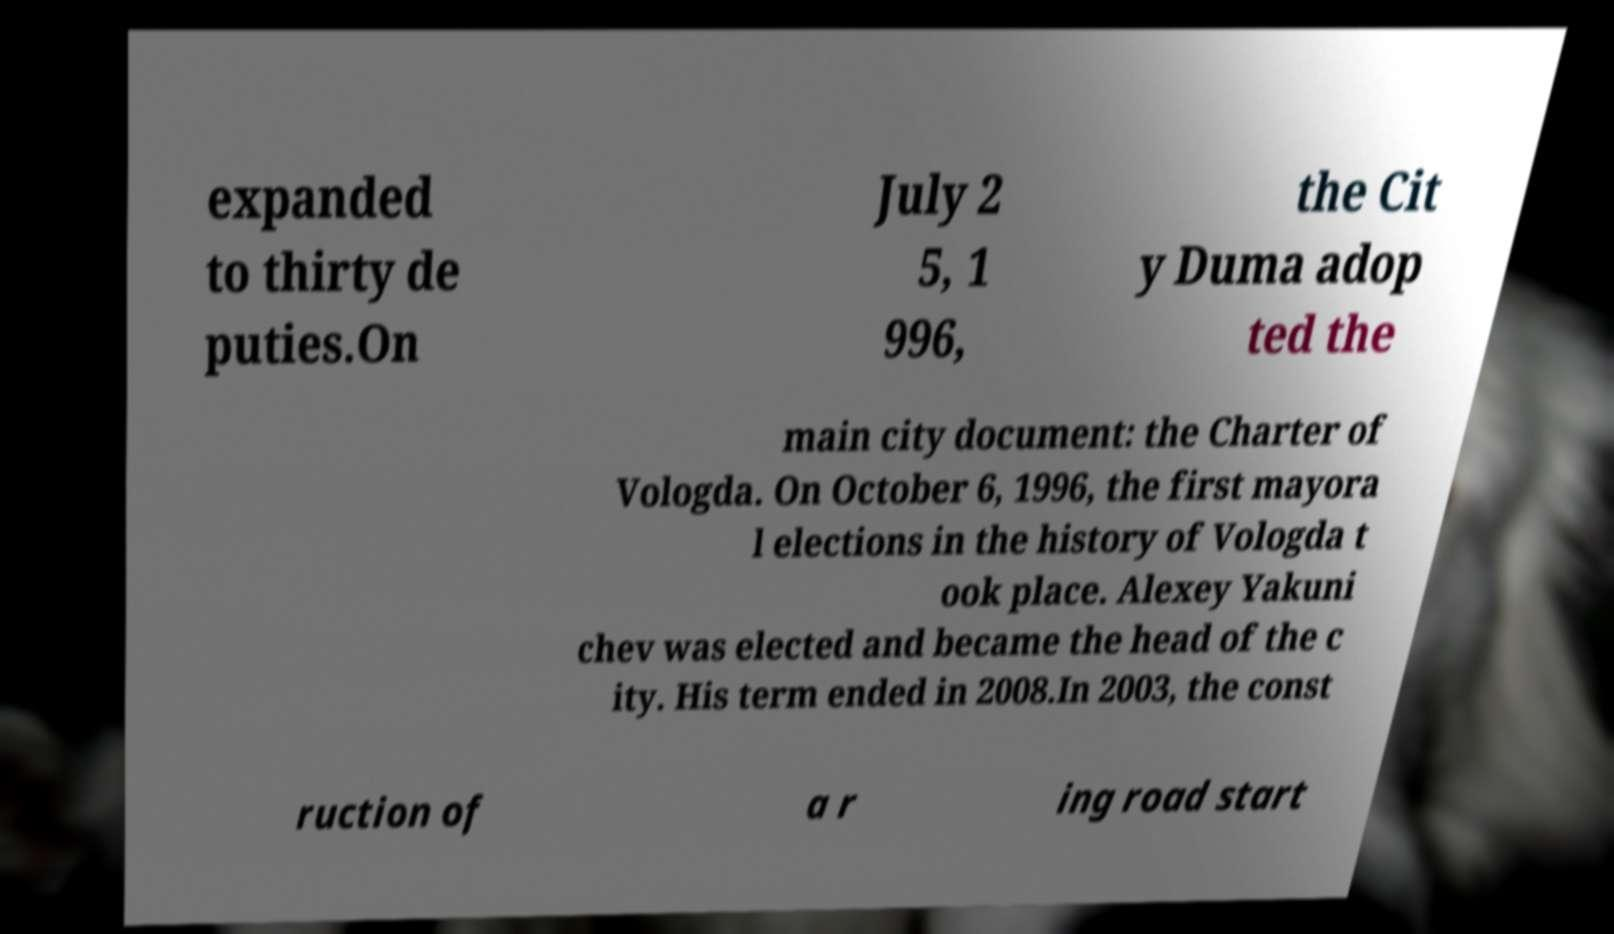What messages or text are displayed in this image? I need them in a readable, typed format. expanded to thirty de puties.On July 2 5, 1 996, the Cit y Duma adop ted the main city document: the Charter of Vologda. On October 6, 1996, the first mayora l elections in the history of Vologda t ook place. Alexey Yakuni chev was elected and became the head of the c ity. His term ended in 2008.In 2003, the const ruction of a r ing road start 